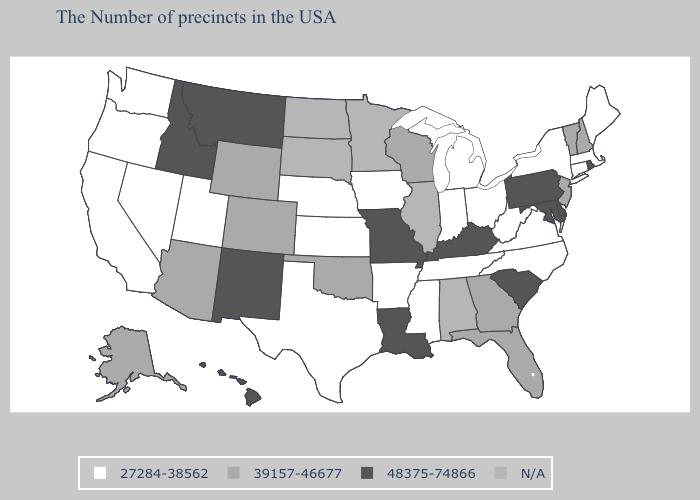Among the states that border Illinois , which have the lowest value?
Be succinct. Indiana, Iowa. What is the lowest value in the Northeast?
Give a very brief answer. 27284-38562. What is the value of Idaho?
Concise answer only. 48375-74866. Name the states that have a value in the range 48375-74866?
Quick response, please. Rhode Island, Delaware, Maryland, Pennsylvania, South Carolina, Kentucky, Louisiana, Missouri, New Mexico, Montana, Idaho, Hawaii. Which states hav the highest value in the MidWest?
Be succinct. Missouri. Name the states that have a value in the range 27284-38562?
Keep it brief. Maine, Massachusetts, Connecticut, New York, Virginia, North Carolina, West Virginia, Ohio, Michigan, Indiana, Tennessee, Mississippi, Arkansas, Iowa, Kansas, Nebraska, Texas, Utah, Nevada, California, Washington, Oregon. What is the value of Pennsylvania?
Concise answer only. 48375-74866. Does South Carolina have the highest value in the USA?
Quick response, please. Yes. What is the highest value in the USA?
Answer briefly. 48375-74866. Does Colorado have the lowest value in the USA?
Keep it brief. No. Among the states that border Texas , which have the lowest value?
Write a very short answer. Arkansas. What is the value of Montana?
Concise answer only. 48375-74866. What is the value of Louisiana?
Give a very brief answer. 48375-74866. 